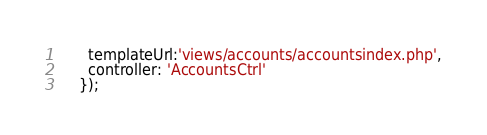<code> <loc_0><loc_0><loc_500><loc_500><_JavaScript_>      templateUrl:'views/accounts/accountsindex.php',
      controller: 'AccountsCtrl'
    });    
</code> 